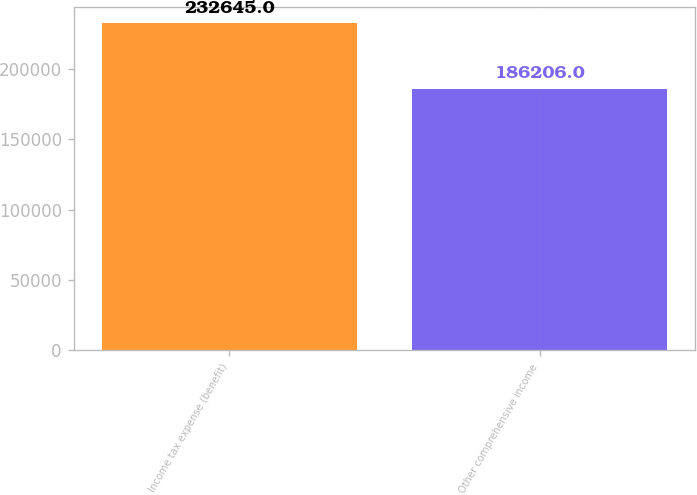<chart> <loc_0><loc_0><loc_500><loc_500><bar_chart><fcel>Income tax expense (benefit)<fcel>Other comprehensive income<nl><fcel>232645<fcel>186206<nl></chart> 